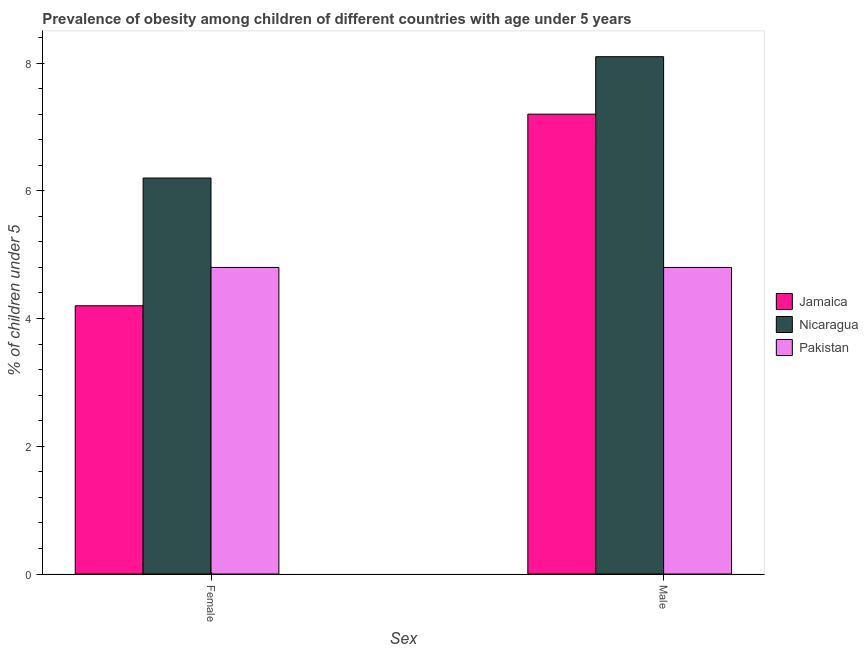How many different coloured bars are there?
Give a very brief answer. 3. How many groups of bars are there?
Offer a very short reply. 2. Are the number of bars per tick equal to the number of legend labels?
Keep it short and to the point. Yes. Are the number of bars on each tick of the X-axis equal?
Give a very brief answer. Yes. How many bars are there on the 2nd tick from the left?
Make the answer very short. 3. How many bars are there on the 1st tick from the right?
Ensure brevity in your answer.  3. What is the percentage of obese female children in Nicaragua?
Ensure brevity in your answer.  6.2. Across all countries, what is the maximum percentage of obese male children?
Offer a very short reply. 8.1. Across all countries, what is the minimum percentage of obese female children?
Provide a succinct answer. 4.2. In which country was the percentage of obese female children maximum?
Ensure brevity in your answer.  Nicaragua. In which country was the percentage of obese female children minimum?
Your answer should be very brief. Jamaica. What is the total percentage of obese male children in the graph?
Your answer should be compact. 20.1. What is the difference between the percentage of obese female children in Jamaica and that in Nicaragua?
Keep it short and to the point. -2. What is the difference between the percentage of obese female children in Nicaragua and the percentage of obese male children in Jamaica?
Give a very brief answer. -1. What is the average percentage of obese female children per country?
Your answer should be very brief. 5.07. What is the difference between the percentage of obese female children and percentage of obese male children in Pakistan?
Ensure brevity in your answer.  0. In how many countries, is the percentage of obese female children greater than 6 %?
Provide a short and direct response. 1. What is the ratio of the percentage of obese female children in Pakistan to that in Jamaica?
Your answer should be very brief. 1.14. What does the 2nd bar from the left in Male represents?
Provide a short and direct response. Nicaragua. What does the 3rd bar from the right in Female represents?
Provide a short and direct response. Jamaica. How many bars are there?
Provide a short and direct response. 6. What is the difference between two consecutive major ticks on the Y-axis?
Offer a terse response. 2. Does the graph contain grids?
Offer a very short reply. No. What is the title of the graph?
Ensure brevity in your answer.  Prevalence of obesity among children of different countries with age under 5 years. What is the label or title of the X-axis?
Your answer should be compact. Sex. What is the label or title of the Y-axis?
Ensure brevity in your answer.   % of children under 5. What is the  % of children under 5 in Jamaica in Female?
Provide a succinct answer. 4.2. What is the  % of children under 5 of Nicaragua in Female?
Provide a succinct answer. 6.2. What is the  % of children under 5 of Pakistan in Female?
Keep it short and to the point. 4.8. What is the  % of children under 5 in Jamaica in Male?
Offer a terse response. 7.2. What is the  % of children under 5 in Nicaragua in Male?
Keep it short and to the point. 8.1. What is the  % of children under 5 in Pakistan in Male?
Make the answer very short. 4.8. Across all Sex, what is the maximum  % of children under 5 of Jamaica?
Offer a terse response. 7.2. Across all Sex, what is the maximum  % of children under 5 in Nicaragua?
Your answer should be compact. 8.1. Across all Sex, what is the maximum  % of children under 5 of Pakistan?
Give a very brief answer. 4.8. Across all Sex, what is the minimum  % of children under 5 of Jamaica?
Keep it short and to the point. 4.2. Across all Sex, what is the minimum  % of children under 5 of Nicaragua?
Make the answer very short. 6.2. Across all Sex, what is the minimum  % of children under 5 of Pakistan?
Your response must be concise. 4.8. What is the total  % of children under 5 in Jamaica in the graph?
Give a very brief answer. 11.4. What is the total  % of children under 5 in Nicaragua in the graph?
Your response must be concise. 14.3. What is the total  % of children under 5 of Pakistan in the graph?
Your answer should be compact. 9.6. What is the difference between the  % of children under 5 of Pakistan in Female and that in Male?
Provide a short and direct response. 0. What is the difference between the  % of children under 5 in Nicaragua in Female and the  % of children under 5 in Pakistan in Male?
Give a very brief answer. 1.4. What is the average  % of children under 5 of Nicaragua per Sex?
Provide a succinct answer. 7.15. What is the difference between the  % of children under 5 in Jamaica and  % of children under 5 in Pakistan in Female?
Make the answer very short. -0.6. What is the difference between the  % of children under 5 of Jamaica and  % of children under 5 of Nicaragua in Male?
Offer a very short reply. -0.9. What is the difference between the  % of children under 5 of Jamaica and  % of children under 5 of Pakistan in Male?
Keep it short and to the point. 2.4. What is the difference between the  % of children under 5 of Nicaragua and  % of children under 5 of Pakistan in Male?
Your answer should be very brief. 3.3. What is the ratio of the  % of children under 5 of Jamaica in Female to that in Male?
Your response must be concise. 0.58. What is the ratio of the  % of children under 5 in Nicaragua in Female to that in Male?
Offer a very short reply. 0.77. What is the difference between the highest and the second highest  % of children under 5 of Nicaragua?
Offer a terse response. 1.9. 